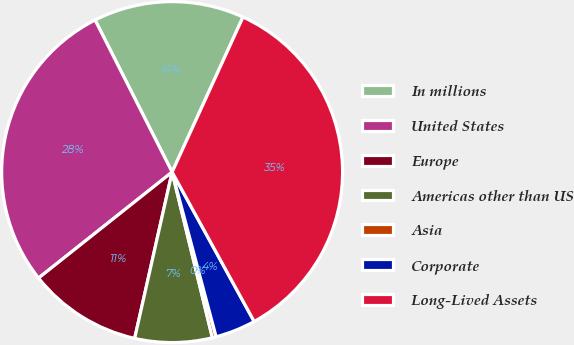Convert chart to OTSL. <chart><loc_0><loc_0><loc_500><loc_500><pie_chart><fcel>In millions<fcel>United States<fcel>Europe<fcel>Americas other than US<fcel>Asia<fcel>Corporate<fcel>Long-Lived Assets<nl><fcel>14.29%<fcel>28.21%<fcel>10.8%<fcel>7.32%<fcel>0.36%<fcel>3.84%<fcel>35.18%<nl></chart> 